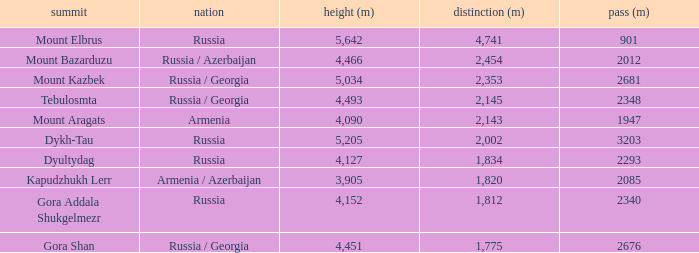What is the Elevation (m) of the Peak with a Prominence (m) larger than 2,143 and Col (m) of 2012? 4466.0. 